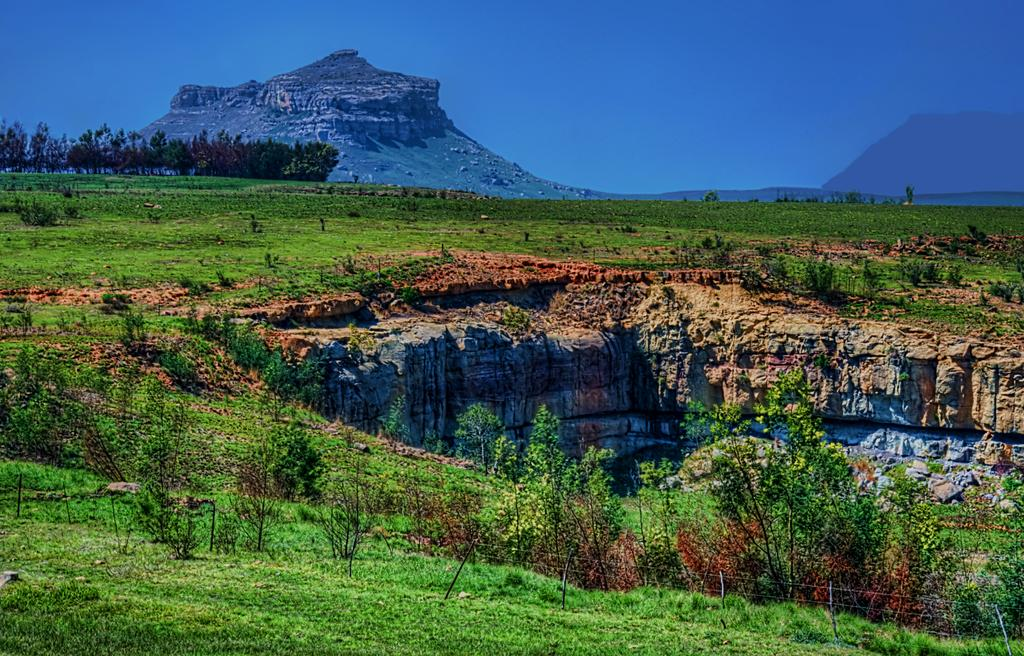What is the dominant color or feature in the image? There is a lot of greenery in the image. Can you describe a specific feature within the greenery? There is a large hole in the greenery. What can be seen around the hole? The hole is surrounded by huge rocks. What can be seen in the distance in the image? There is a mountain visible in the background of the image. What type of jam is being spread on the rocks in the image? There is no jam present in the image; it features a large hole surrounded by huge rocks and a mountain in the background. 